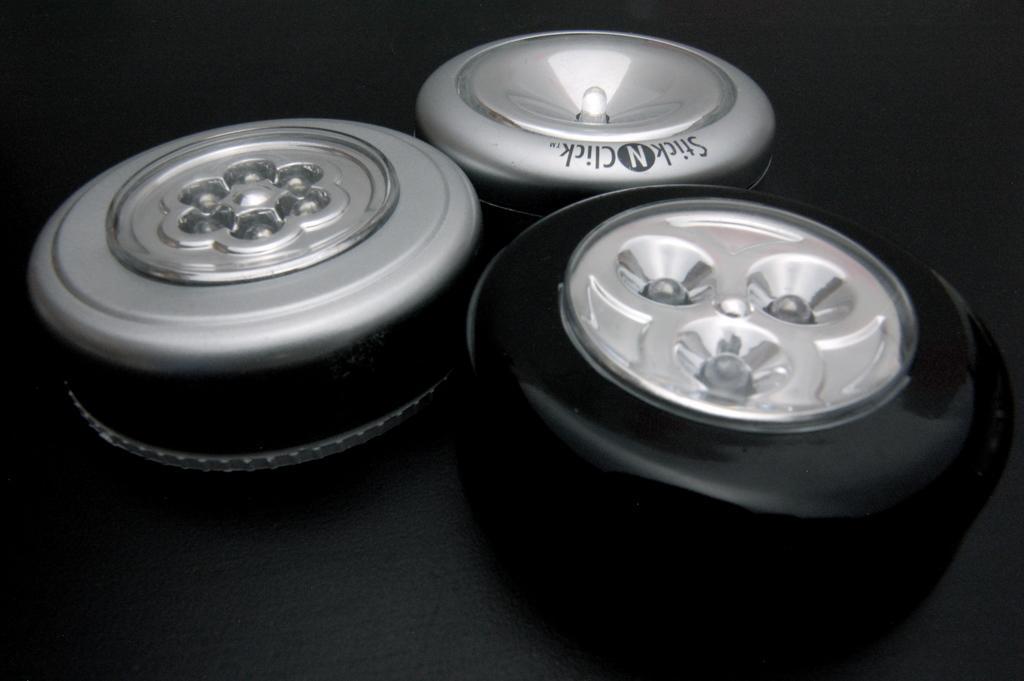How would you summarize this image in a sentence or two? In this picture we can see few LED lights and dark background. 